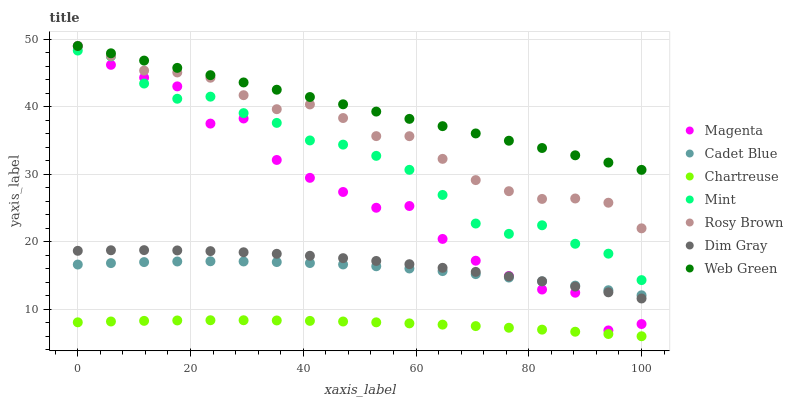Does Chartreuse have the minimum area under the curve?
Answer yes or no. Yes. Does Web Green have the maximum area under the curve?
Answer yes or no. Yes. Does Rosy Brown have the minimum area under the curve?
Answer yes or no. No. Does Rosy Brown have the maximum area under the curve?
Answer yes or no. No. Is Web Green the smoothest?
Answer yes or no. Yes. Is Magenta the roughest?
Answer yes or no. Yes. Is Rosy Brown the smoothest?
Answer yes or no. No. Is Rosy Brown the roughest?
Answer yes or no. No. Does Chartreuse have the lowest value?
Answer yes or no. Yes. Does Rosy Brown have the lowest value?
Answer yes or no. No. Does Magenta have the highest value?
Answer yes or no. Yes. Does Chartreuse have the highest value?
Answer yes or no. No. Is Chartreuse less than Cadet Blue?
Answer yes or no. Yes. Is Rosy Brown greater than Mint?
Answer yes or no. Yes. Does Web Green intersect Rosy Brown?
Answer yes or no. Yes. Is Web Green less than Rosy Brown?
Answer yes or no. No. Is Web Green greater than Rosy Brown?
Answer yes or no. No. Does Chartreuse intersect Cadet Blue?
Answer yes or no. No. 